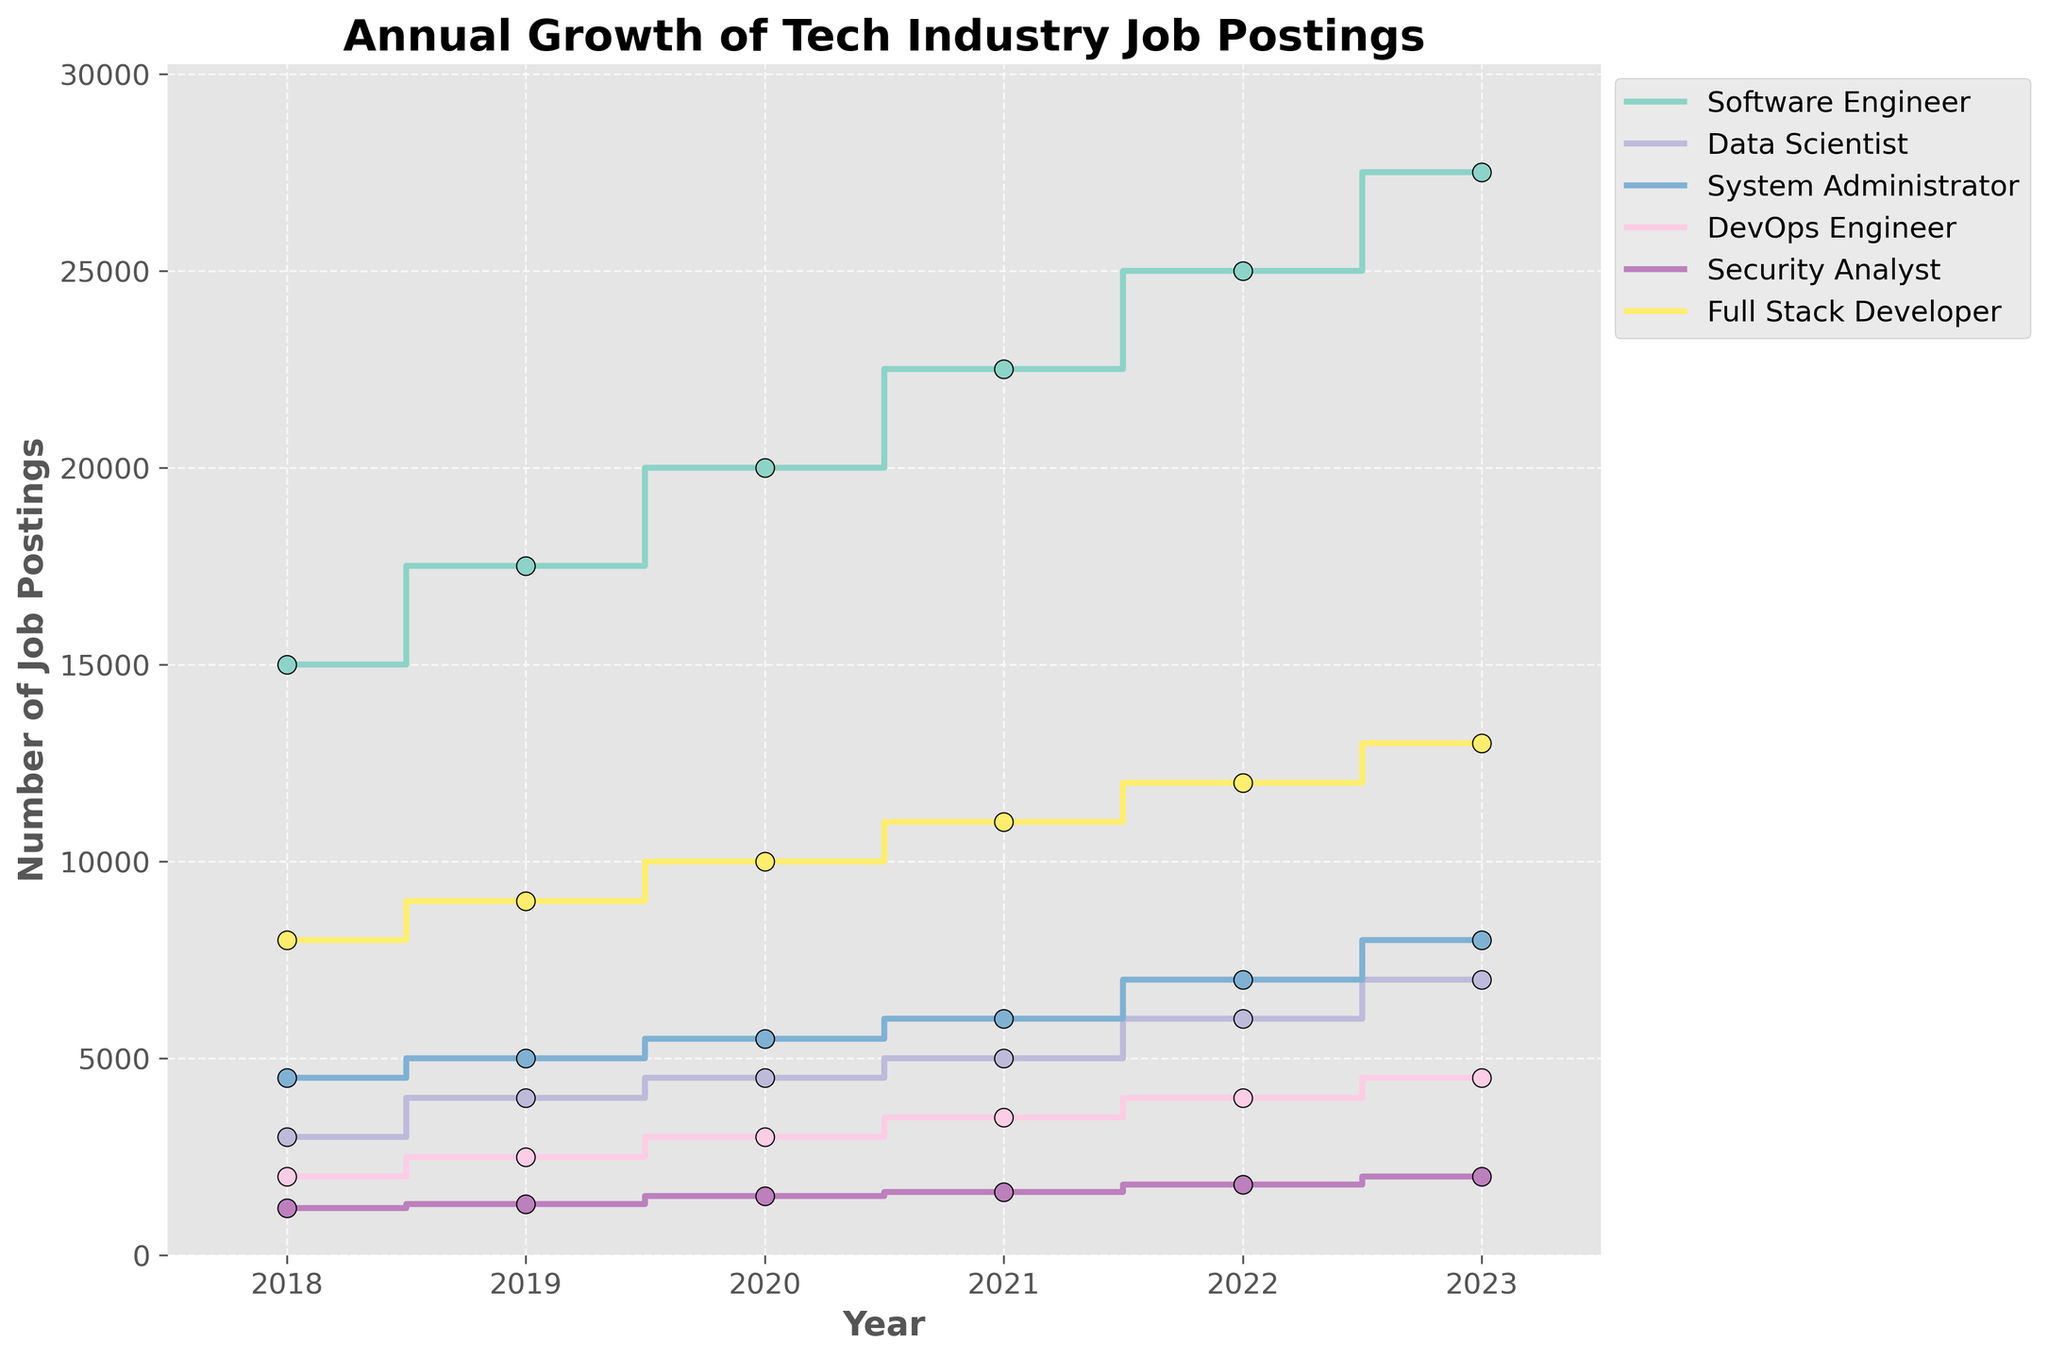What role had the most job postings in 2023? Looking at the rightmost end of the stair plot, the red line corresponding to 'Software Engineer' reaches the highest value compared to other roles in 2023.
Answer: Software Engineer Which year saw the highest increase in job postings for Data Scientists? By observing the steepness of the lines throughout the years, the step for Data Scientists appears steepest between 2018 and 2019, indicating the highest increase in that period.
Answer: 2019 What was the total number of job postings for all roles in 2020? Summing up the values for different roles in 2020: 20000 (Software Engineer) + 4500 (Data Scientist) + 5500 (System Administrator) + 3000 (DevOps Engineer) + 1500 (Security Analyst) + 10000 (Full Stack Developer) = 44500
Answer: 44500 Which role experienced continuous growth each year? All lines are non-decreasing, but each line indicates there's continuous growth for every role from 2018 to 2023. Hence, all roles experienced continuous growth.
Answer: All roles By how much did the number of job postings for Full Stack Developers increase from 2018 to 2023? Subtract the 2018 value from the 2023 value for Full Stack Developer: 13000 - 8000 = 5000
Answer: 5000 Among DevOps Engineers and Security Analysts, which role saw larger growth from 2020 to 2021, and by how much? Find the difference between 2021 and 2020 for both roles and compare: DevOps Engineer: 3500 - 3000 = 500, Security Analyst: 1600 - 1500 = 100. DevOps Engineer had a larger growth by 400 (500 - 100).
Answer: DevOps Engineer, by 400 In which year did Software Engineer roles surpass 20000 job postings? Check the point on the graph where the blue line crosses 20000, which is in 2020.
Answer: 2020 How many more job postings were there for Security Analysts in 2022 compared to 2018? Subtract the 2018 value from the 2022 value for Security Analyst: 1800 - 1200 = 600
Answer: 600 